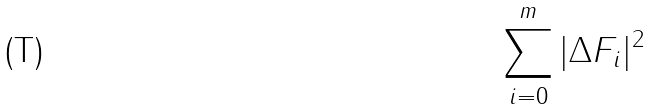<formula> <loc_0><loc_0><loc_500><loc_500>\sum _ { i = 0 } ^ { m } | \Delta F _ { i } | ^ { 2 }</formula> 